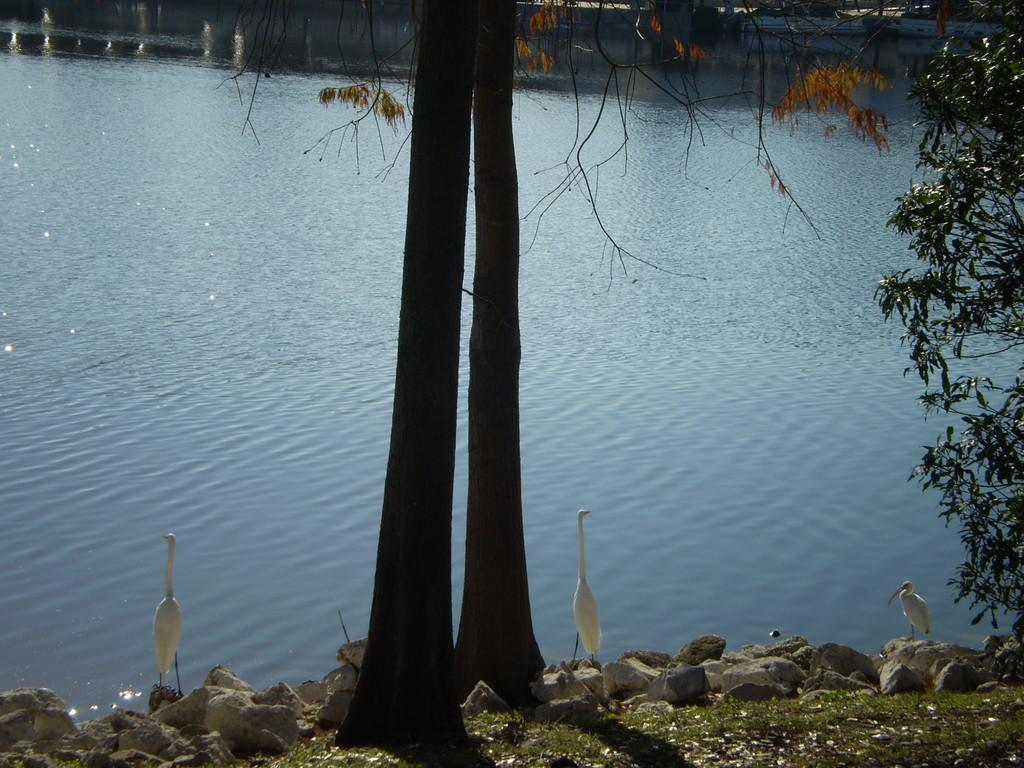What body of water is present in the image? There is a lake in the image. What type of vegetation is in the foreground of the image? There are trees in the foreground of the image. What type of animals can be seen in the image? Birds are visible in the image. What type of objects are in front of the lake? Stones are visible in front of the lake. Where is the cushion located in the image? There is no cushion present in the image. What type of police presence can be seen in the image? There is no police presence in the image. 